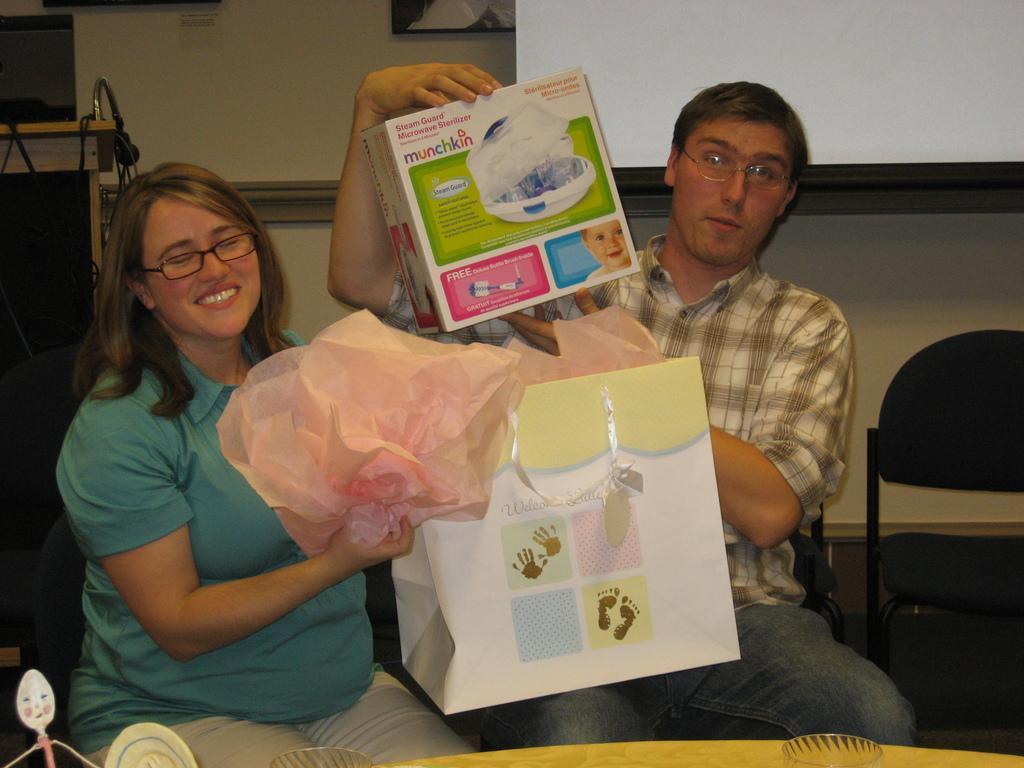Please provide a concise description of this image. In this image I see a woman and a man who are sitting on chairs and I see this woman is smiling and holding a paper in her hands and this guy is holding a box in his hands. I can also see another chair over here. In the background I see the white screen, wall and a mic over here. 